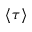Convert formula to latex. <formula><loc_0><loc_0><loc_500><loc_500>\langle \tau \rangle</formula> 